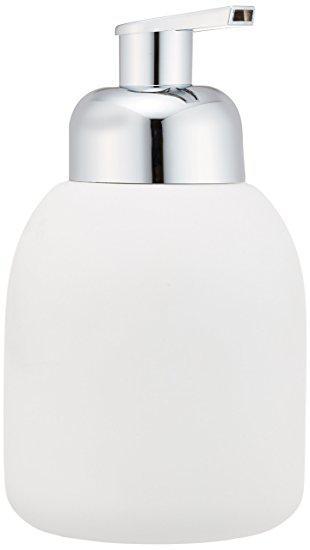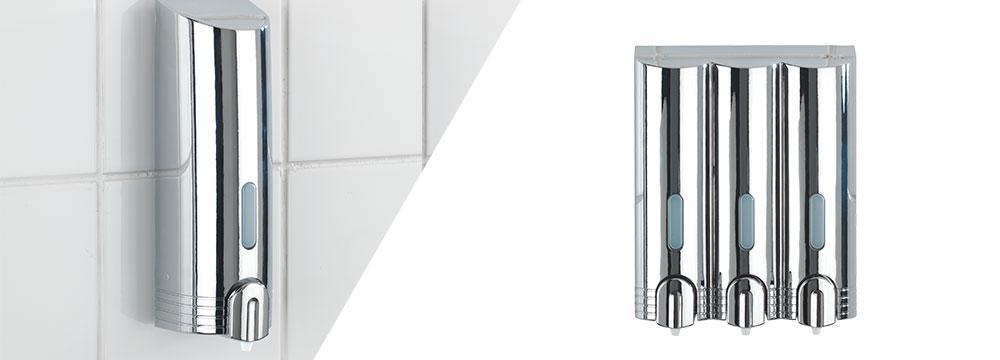The first image is the image on the left, the second image is the image on the right. Considering the images on both sides, is "There is a silver dispenser with three nozzles in the right image." valid? Answer yes or no. Yes. The first image is the image on the left, the second image is the image on the right. Evaluate the accuracy of this statement regarding the images: "There is one round soap dispenser with the spout pointing to the left.". Is it true? Answer yes or no. No. 